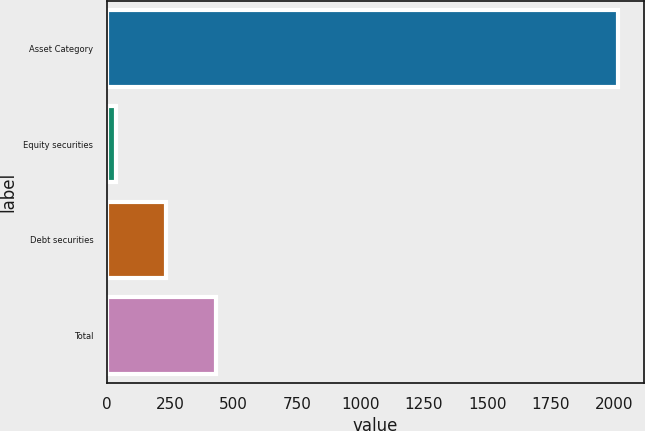Convert chart. <chart><loc_0><loc_0><loc_500><loc_500><bar_chart><fcel>Asset Category<fcel>Equity securities<fcel>Debt securities<fcel>Total<nl><fcel>2015<fcel>36<fcel>233.9<fcel>431.8<nl></chart> 